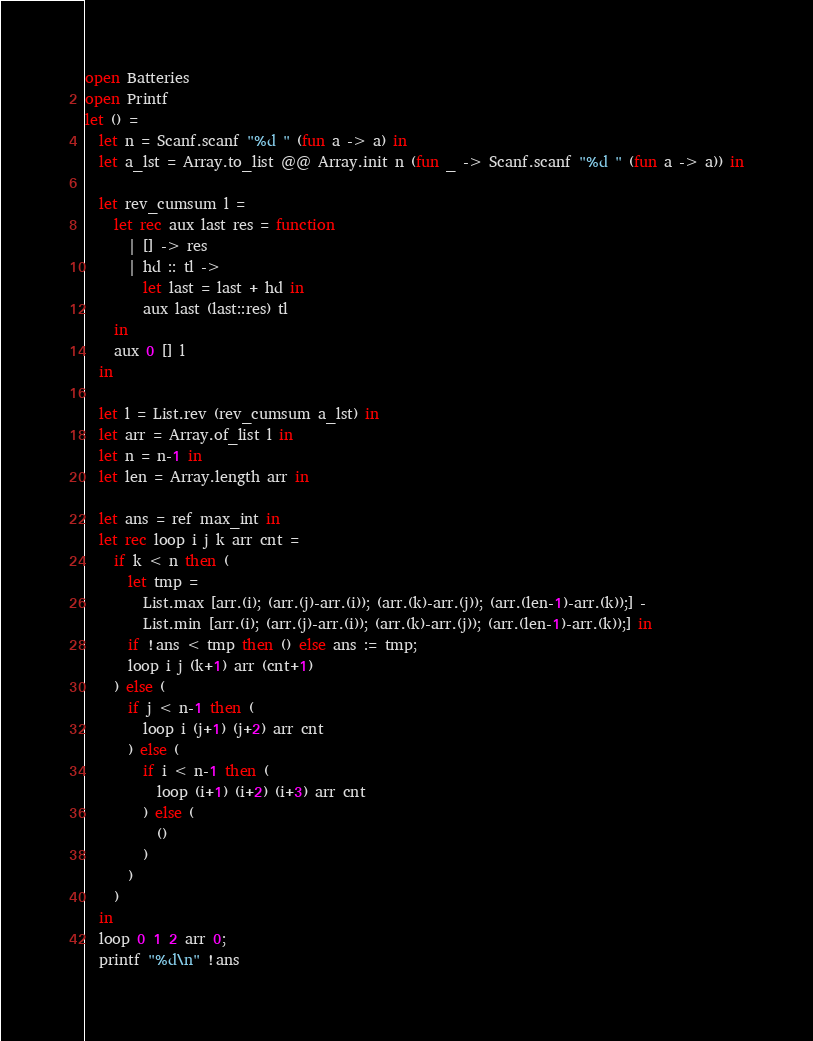Convert code to text. <code><loc_0><loc_0><loc_500><loc_500><_OCaml_>open Batteries
open Printf
let () =
  let n = Scanf.scanf "%d " (fun a -> a) in
  let a_lst = Array.to_list @@ Array.init n (fun _ -> Scanf.scanf "%d " (fun a -> a)) in

  let rev_cumsum l =
    let rec aux last res = function
      | [] -> res
      | hd :: tl -> 
        let last = last + hd in
        aux last (last::res) tl
    in
    aux 0 [] l
  in

  let l = List.rev (rev_cumsum a_lst) in
  let arr = Array.of_list l in
  let n = n-1 in
  let len = Array.length arr in

  let ans = ref max_int in
  let rec loop i j k arr cnt =
    if k < n then (
      let tmp =
        List.max [arr.(i); (arr.(j)-arr.(i)); (arr.(k)-arr.(j)); (arr.(len-1)-arr.(k));] -
        List.min [arr.(i); (arr.(j)-arr.(i)); (arr.(k)-arr.(j)); (arr.(len-1)-arr.(k));] in
      if !ans < tmp then () else ans := tmp;
      loop i j (k+1) arr (cnt+1)
    ) else (
      if j < n-1 then (
        loop i (j+1) (j+2) arr cnt
      ) else (
        if i < n-1 then (
          loop (i+1) (i+2) (i+3) arr cnt
        ) else (
          ()
        )
      )
    )
  in
  loop 0 1 2 arr 0;
  printf "%d\n" !ans
</code> 